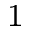<formula> <loc_0><loc_0><loc_500><loc_500>^ { \, 1 }</formula> 